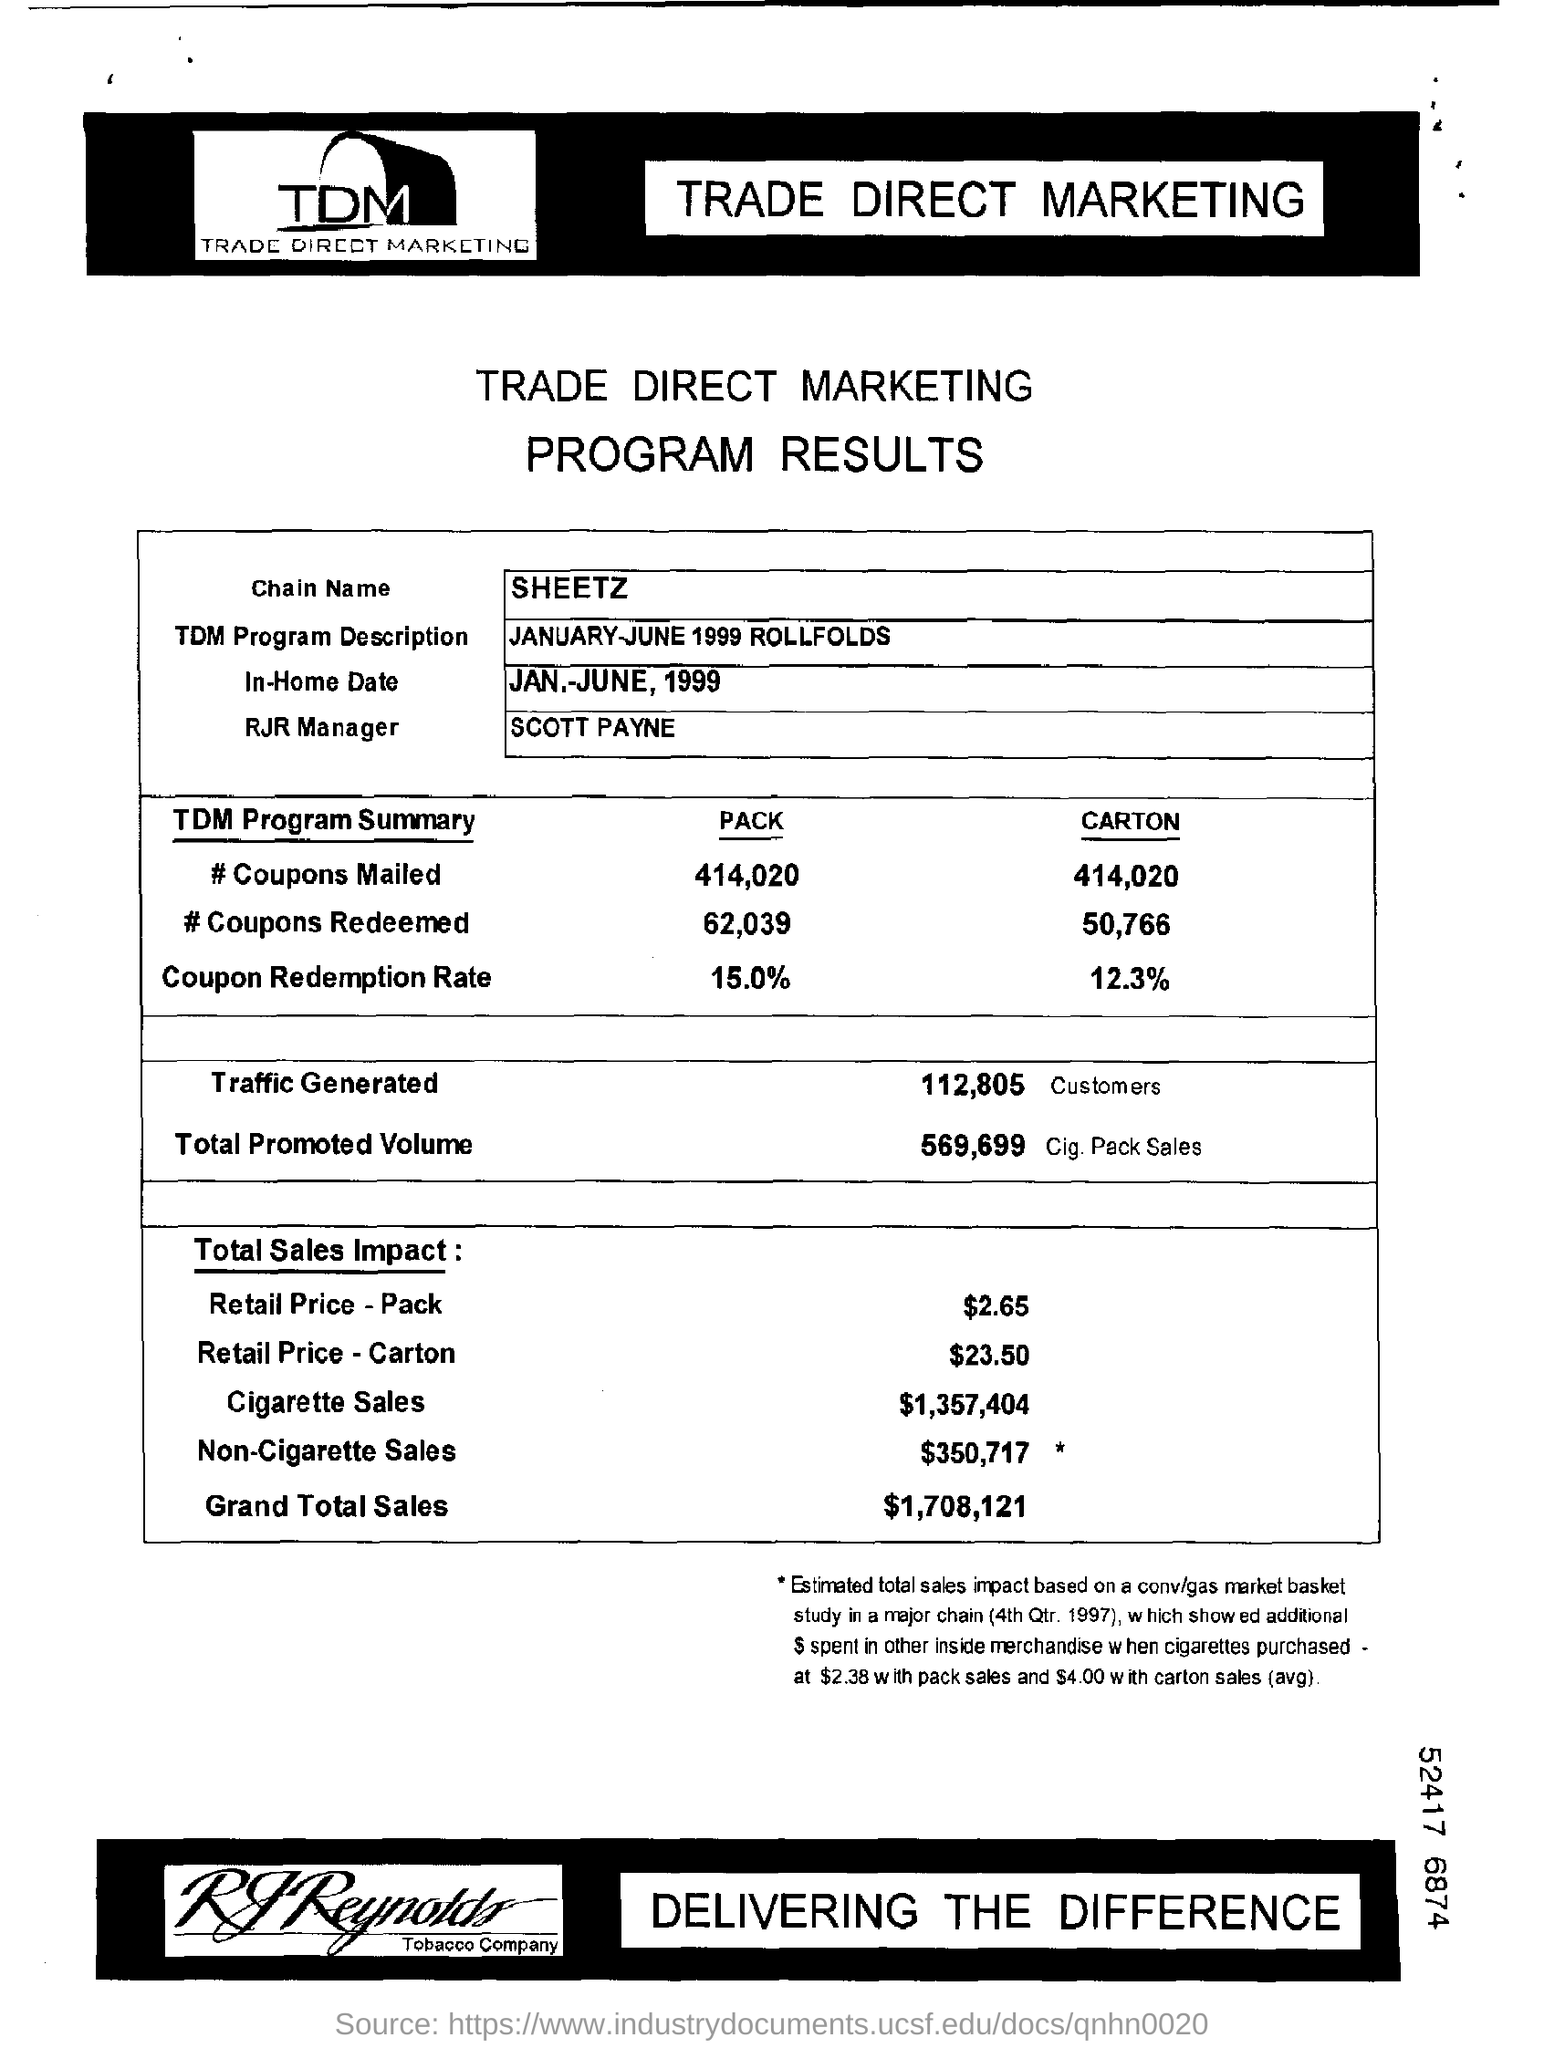Indicate a few pertinent items in this graphic. The redemption rate of coupons was 12.3%. We mailed a total of 414,020 packs of coupons. The TDM Program Description for January-June 1999 included rollfolds providing information on the program's objective, scope, and implementation. The redemption rate for coupons was 15.0%. Scott Payne is the RJR Manager. 